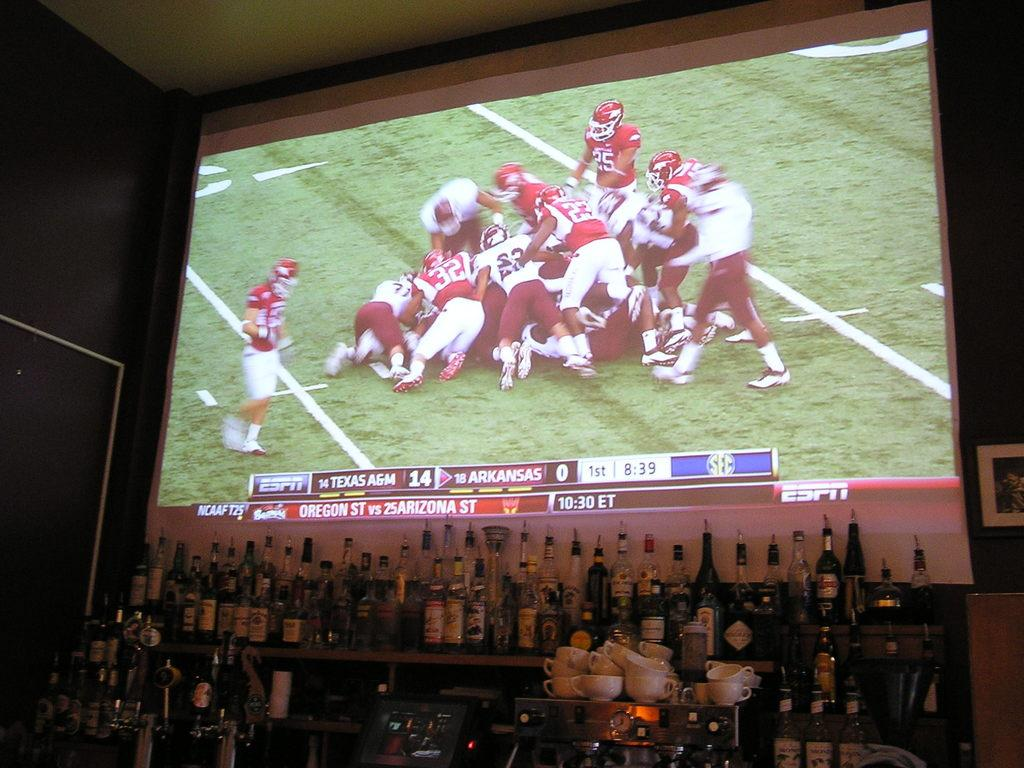Provide a one-sentence caption for the provided image. A huge screen playing a football gameon ESPN behind the bar. 